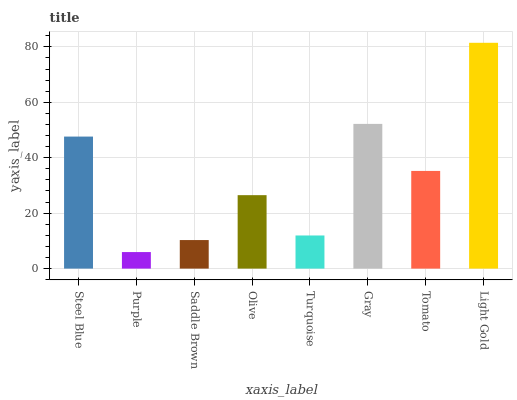Is Purple the minimum?
Answer yes or no. Yes. Is Light Gold the maximum?
Answer yes or no. Yes. Is Saddle Brown the minimum?
Answer yes or no. No. Is Saddle Brown the maximum?
Answer yes or no. No. Is Saddle Brown greater than Purple?
Answer yes or no. Yes. Is Purple less than Saddle Brown?
Answer yes or no. Yes. Is Purple greater than Saddle Brown?
Answer yes or no. No. Is Saddle Brown less than Purple?
Answer yes or no. No. Is Tomato the high median?
Answer yes or no. Yes. Is Olive the low median?
Answer yes or no. Yes. Is Light Gold the high median?
Answer yes or no. No. Is Light Gold the low median?
Answer yes or no. No. 